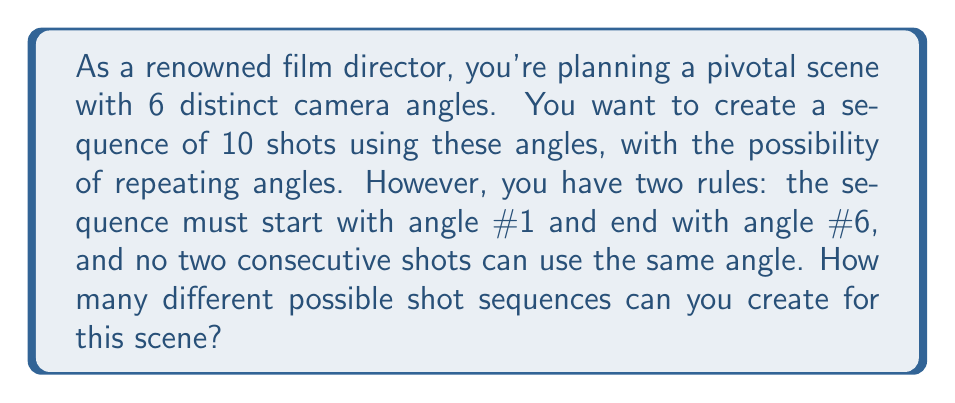Teach me how to tackle this problem. Let's approach this step-by-step:

1) We know the first and last shots are fixed (angle #1 and #6 respectively), so we need to determine the possibilities for the 8 shots in between.

2) For each of these 8 shots, we have 5 choices (all angles except the one used in the previous shot).

3) This scenario can be modeled as a multiplication principle problem.

4) For the 2nd shot, we have 5 choices (any angle except #1).
   For the 3rd shot, we have 5 choices (any angle except the one used in the 2nd shot).
   This pattern continues for all 8 shots.

5) Therefore, the total number of possibilities is:

   $$5 \times 5 \times 5 \times 5 \times 5 \times 5 \times 5 \times 5 = 5^8$$

6) We can also write this as:

   $$5^8 = 390,625$$

This represents the number of different ways to arrange the middle 8 shots, given our constraints.
Answer: $390,625$ possible shot sequences 